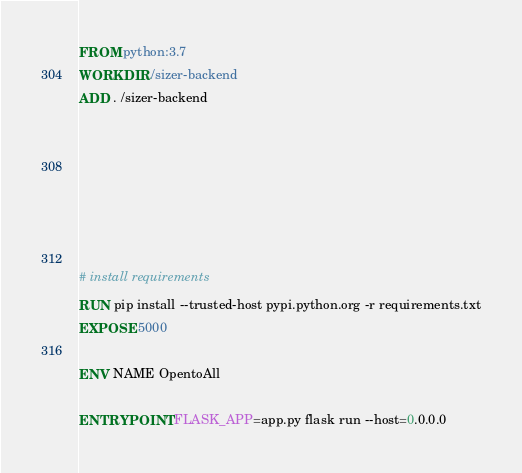Convert code to text. <code><loc_0><loc_0><loc_500><loc_500><_Dockerfile_>FROM python:3.7
WORKDIR /sizer-backend
ADD . /sizer-backend







# install requirements
RUN pip install --trusted-host pypi.python.org -r requirements.txt
EXPOSE 5000

ENV NAME OpentoAll

ENTRYPOINT FLASK_APP=app.py flask run --host=0.0.0.0</code> 